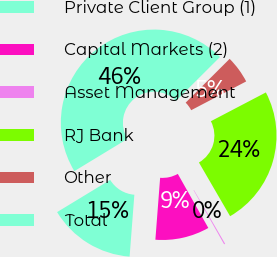Convert chart. <chart><loc_0><loc_0><loc_500><loc_500><pie_chart><fcel>Private Client Group (1)<fcel>Capital Markets (2)<fcel>Asset Management<fcel>RJ Bank<fcel>Other<fcel>Total<nl><fcel>15.09%<fcel>9.4%<fcel>0.19%<fcel>24.3%<fcel>4.8%<fcel>46.21%<nl></chart> 